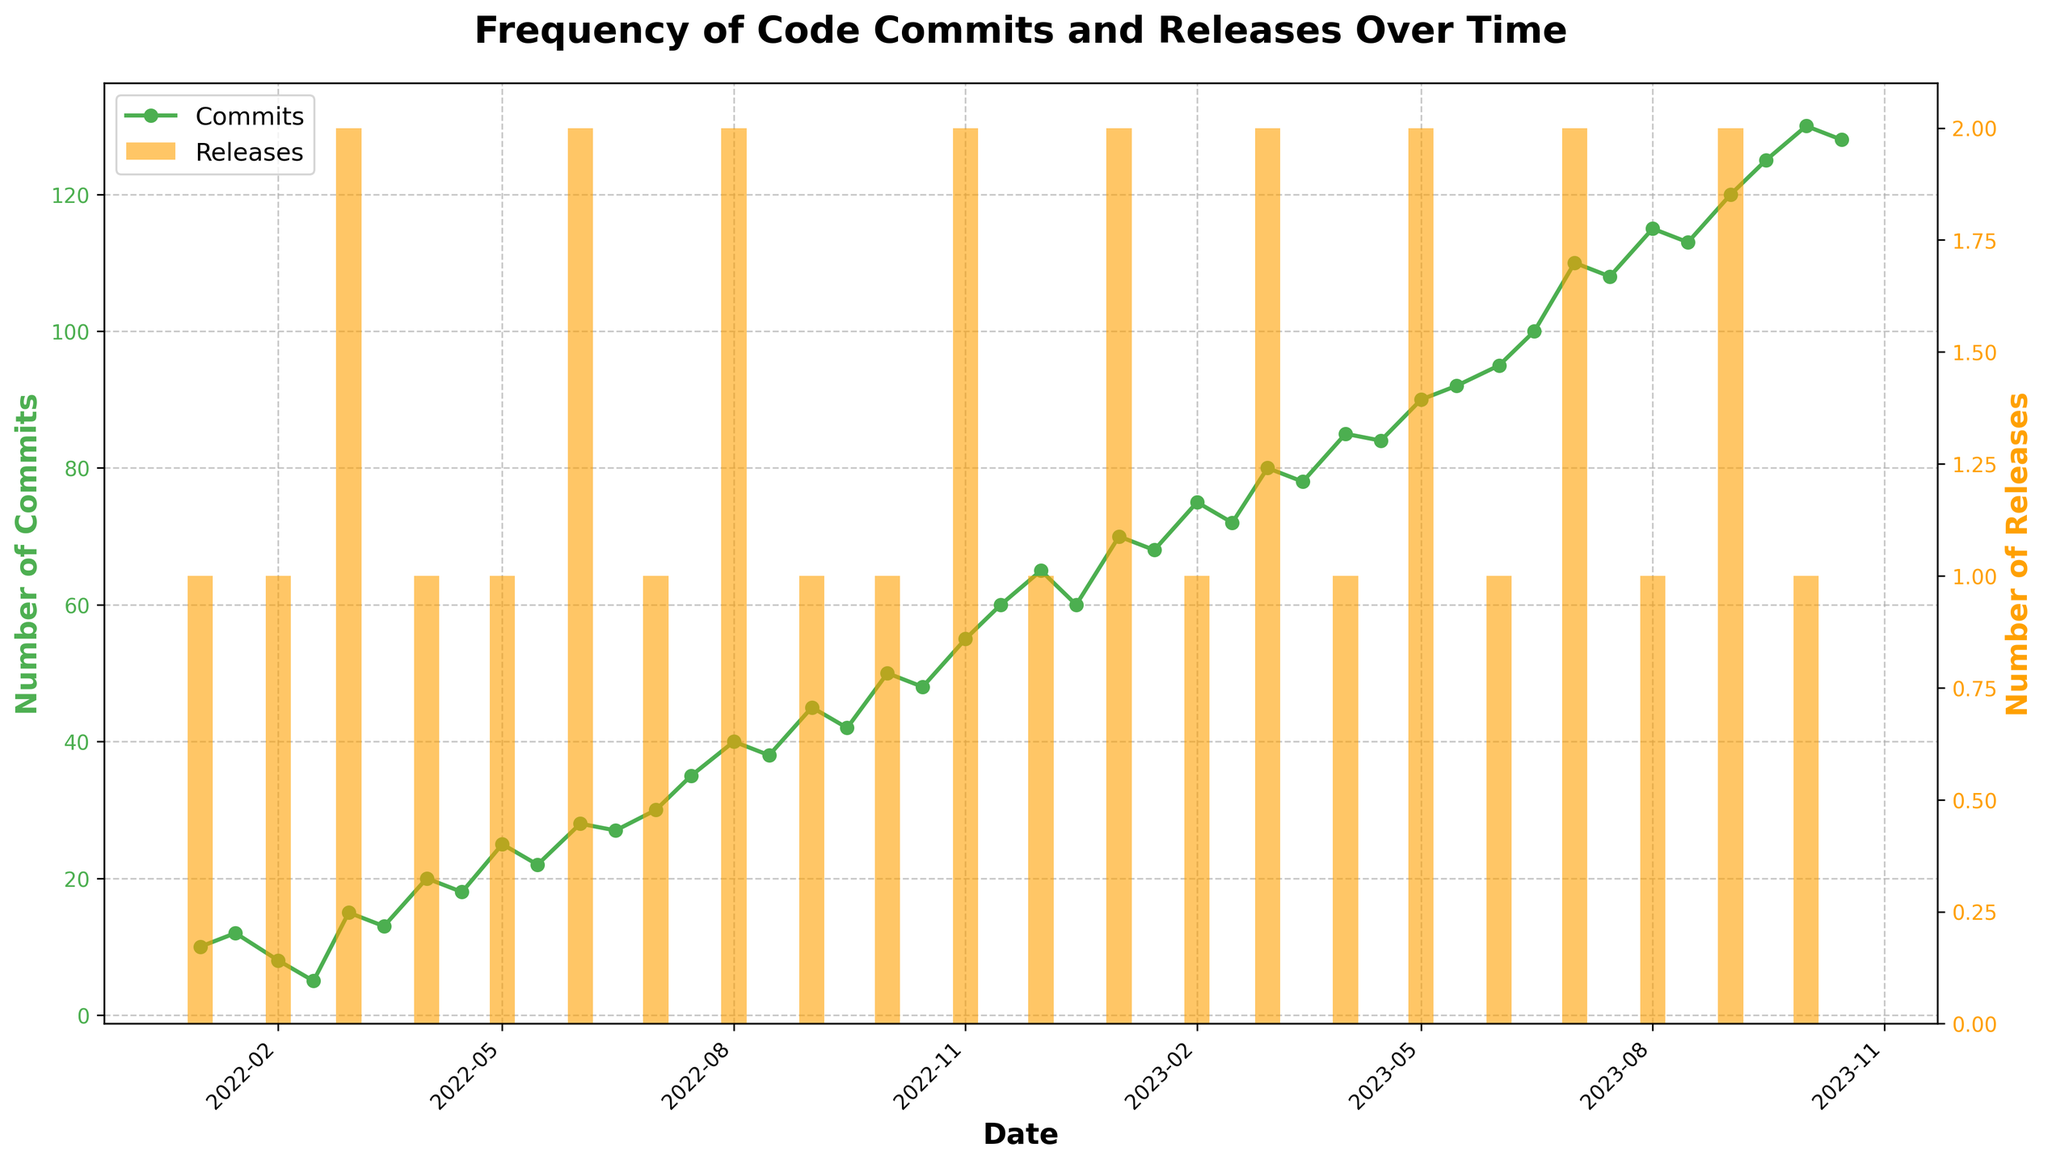What is the title of the plot? The title is usually located at the top of the figure and specifies what the plot represents. It's a way to quickly understand the content of the plot.
Answer: Frequency of Code Commits and Releases Over Time How do the number of commits and releases change over time? By observing the plot, the number of commits gradually increases over time, while the number of releases shows periodic spikes every month or so without a clear increasing or decreasing trend.
Answer: Commits increase, releases show periodic spikes What date had the highest number of commits, and how many were there? The highest number of commits is the peak point on the green line. By identifying the maximum point, we can check the corresponding date on the x-axis.
Answer: September 15, 2023, with 125 commits How many releases were there in June 2022? To find this, locate the bars in June 2022 and check the heights, which represent the number of releases.
Answer: 2 What is the average number of commits from January 2022 to December 2022? Sum the commits for each data point between January and December 2022, then divide by the number of data points within this range.
Answer: (10 + 12 + 8 + 5 + 15 + 13 + 20 + 18 + 25 + 22 + 28 + 27 + 30 + 35 + 40 + 38 + 45 + 42 + 50 + 48 + 55 + 60 + 65 + 60) / 24 = 30.17 Which month had more commits, March 2022 or March 2023? Compare the value of commits from the data points corresponding to March 2022 and March 2023.
Answer: March 2023 had more commits How many times were there exactly 2 releases, and in which months? Identify and count the months where the height of the yellow bars equals 2 and note the corresponding months.
Answer: 7 times: March 2022, June 2022, August 2022, November 2022, January 2023, March 2023, May 2023 Is there any significant trend observed between commits and releases? By observing both the green lines and yellow bars for their correlation or any specific pattern, we can determine if a significant trend exists.
Answer: No significant correlation What is the difference in the number of commits between the start and end of the period? Subtract the number of commits at the start date (January 2022) from the number of commits at the end date (October 2023).
Answer: 130 - 10 = 120 Which month had the highest number of releases and how many? Identify the tallest yellow bar in the plot and note the x-axis for the corresponding month.
Answer: November 2022 with 2 releases 